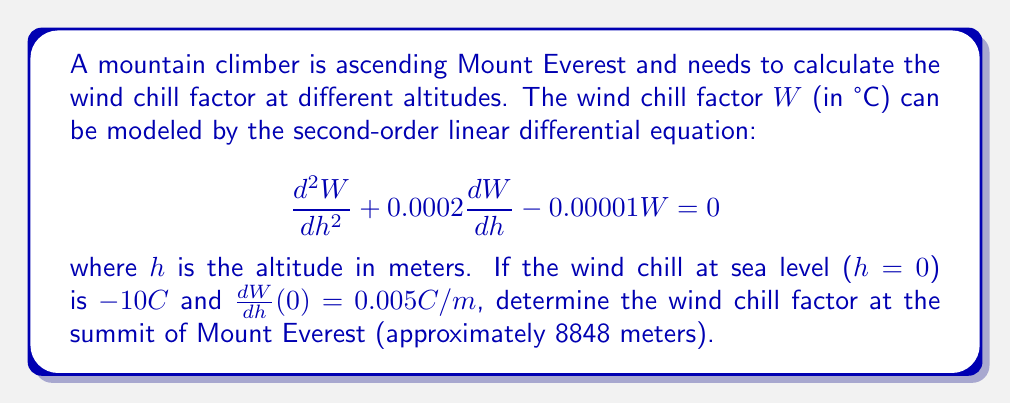Provide a solution to this math problem. To solve this problem, we need to follow these steps:

1) The general solution for this second-order linear differential equation is:

   $$W(h) = C_1e^{r_1h} + C_2e^{r_2h}$$

   where $r_1$ and $r_2$ are the roots of the characteristic equation:

   $$r^2 + 0.0002r - 0.00001 = 0$$

2) Solving the characteristic equation:
   
   $$r = \frac{-0.0002 \pm \sqrt{0.0002^2 + 4(0.00001)}}{2} = \frac{-0.0002 \pm 0.00632456}{2}$$

   $$r_1 \approx 0.00306228, r_2 \approx -0.00326228$$

3) So, our general solution is:

   $$W(h) = C_1e^{0.00306228h} + C_2e^{-0.00326228h}$$

4) Now we use the initial conditions to find $C_1$ and $C_2$:

   At $h=0$, $W(0) = -10$, so:
   $$-10 = C_1 + C_2$$

   For $\frac{dW}{dh}(0) = 0.005$:
   $$\frac{dW}{dh} = 0.00306228C_1e^{0.00306228h} - 0.00326228C_2e^{-0.00326228h}$$
   $$0.005 = 0.00306228C_1 - 0.00326228C_2$$

5) Solving these equations simultaneously:

   $$C_1 \approx -4.91532, C_2 \approx -5.08468$$

6) Our particular solution is therefore:

   $$W(h) = -4.91532e^{0.00306228h} - 5.08468e^{-0.00326228h}$$

7) To find the wind chill at the summit, we substitute $h = 8848$:

   $$W(8848) = -4.91532e^{0.00306228(8848)} - 5.08468e^{-0.00326228(8848)}$$

8) Calculating this gives us the final answer.
Answer: The wind chill factor at the summit of Mount Everest (8848 meters) is approximately $-44.7°C$. 